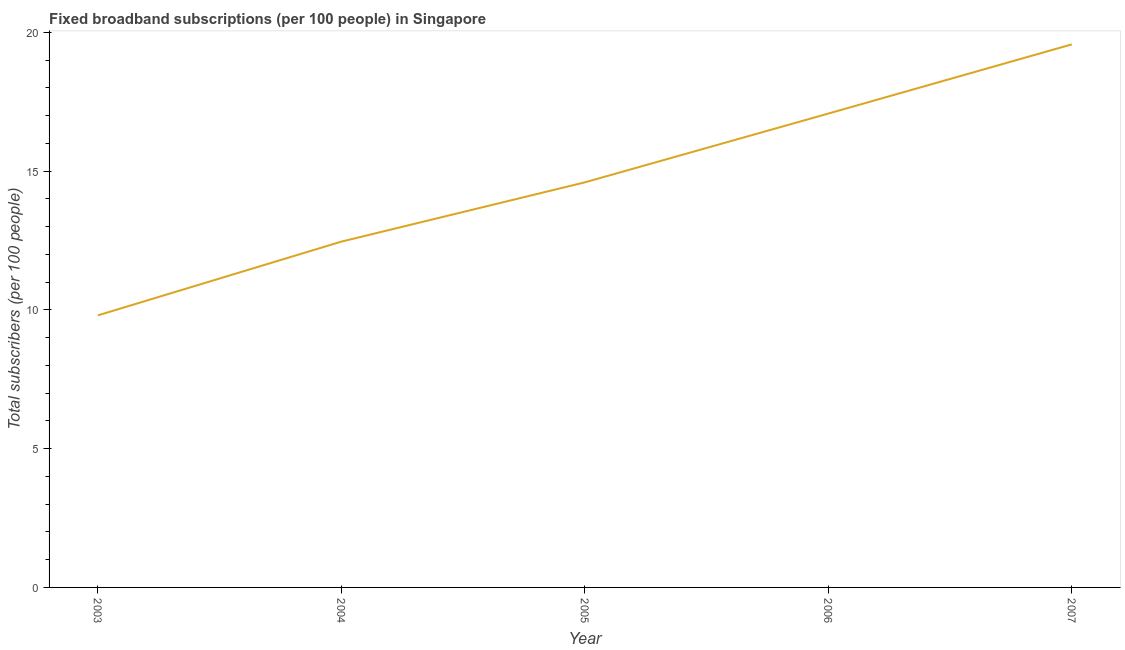What is the total number of fixed broadband subscriptions in 2004?
Make the answer very short. 12.46. Across all years, what is the maximum total number of fixed broadband subscriptions?
Offer a terse response. 19.57. Across all years, what is the minimum total number of fixed broadband subscriptions?
Offer a terse response. 9.8. In which year was the total number of fixed broadband subscriptions maximum?
Your answer should be very brief. 2007. What is the sum of the total number of fixed broadband subscriptions?
Your answer should be very brief. 73.5. What is the difference between the total number of fixed broadband subscriptions in 2003 and 2004?
Your response must be concise. -2.66. What is the average total number of fixed broadband subscriptions per year?
Ensure brevity in your answer.  14.7. What is the median total number of fixed broadband subscriptions?
Offer a terse response. 14.6. What is the ratio of the total number of fixed broadband subscriptions in 2003 to that in 2004?
Give a very brief answer. 0.79. Is the total number of fixed broadband subscriptions in 2003 less than that in 2007?
Provide a succinct answer. Yes. What is the difference between the highest and the second highest total number of fixed broadband subscriptions?
Offer a terse response. 2.49. What is the difference between the highest and the lowest total number of fixed broadband subscriptions?
Provide a short and direct response. 9.77. How many years are there in the graph?
Ensure brevity in your answer.  5. Are the values on the major ticks of Y-axis written in scientific E-notation?
Keep it short and to the point. No. What is the title of the graph?
Offer a terse response. Fixed broadband subscriptions (per 100 people) in Singapore. What is the label or title of the X-axis?
Your answer should be very brief. Year. What is the label or title of the Y-axis?
Your response must be concise. Total subscribers (per 100 people). What is the Total subscribers (per 100 people) in 2003?
Keep it short and to the point. 9.8. What is the Total subscribers (per 100 people) of 2004?
Provide a short and direct response. 12.46. What is the Total subscribers (per 100 people) in 2005?
Provide a short and direct response. 14.6. What is the Total subscribers (per 100 people) of 2006?
Your answer should be very brief. 17.08. What is the Total subscribers (per 100 people) of 2007?
Your answer should be very brief. 19.57. What is the difference between the Total subscribers (per 100 people) in 2003 and 2004?
Your answer should be compact. -2.66. What is the difference between the Total subscribers (per 100 people) in 2003 and 2005?
Ensure brevity in your answer.  -4.79. What is the difference between the Total subscribers (per 100 people) in 2003 and 2006?
Provide a succinct answer. -7.27. What is the difference between the Total subscribers (per 100 people) in 2003 and 2007?
Your response must be concise. -9.77. What is the difference between the Total subscribers (per 100 people) in 2004 and 2005?
Give a very brief answer. -2.14. What is the difference between the Total subscribers (per 100 people) in 2004 and 2006?
Offer a very short reply. -4.61. What is the difference between the Total subscribers (per 100 people) in 2004 and 2007?
Provide a short and direct response. -7.11. What is the difference between the Total subscribers (per 100 people) in 2005 and 2006?
Provide a succinct answer. -2.48. What is the difference between the Total subscribers (per 100 people) in 2005 and 2007?
Keep it short and to the point. -4.97. What is the difference between the Total subscribers (per 100 people) in 2006 and 2007?
Give a very brief answer. -2.49. What is the ratio of the Total subscribers (per 100 people) in 2003 to that in 2004?
Offer a terse response. 0.79. What is the ratio of the Total subscribers (per 100 people) in 2003 to that in 2005?
Give a very brief answer. 0.67. What is the ratio of the Total subscribers (per 100 people) in 2003 to that in 2006?
Your response must be concise. 0.57. What is the ratio of the Total subscribers (per 100 people) in 2003 to that in 2007?
Provide a succinct answer. 0.5. What is the ratio of the Total subscribers (per 100 people) in 2004 to that in 2005?
Make the answer very short. 0.85. What is the ratio of the Total subscribers (per 100 people) in 2004 to that in 2006?
Your response must be concise. 0.73. What is the ratio of the Total subscribers (per 100 people) in 2004 to that in 2007?
Your answer should be very brief. 0.64. What is the ratio of the Total subscribers (per 100 people) in 2005 to that in 2006?
Your response must be concise. 0.85. What is the ratio of the Total subscribers (per 100 people) in 2005 to that in 2007?
Your answer should be very brief. 0.75. What is the ratio of the Total subscribers (per 100 people) in 2006 to that in 2007?
Keep it short and to the point. 0.87. 